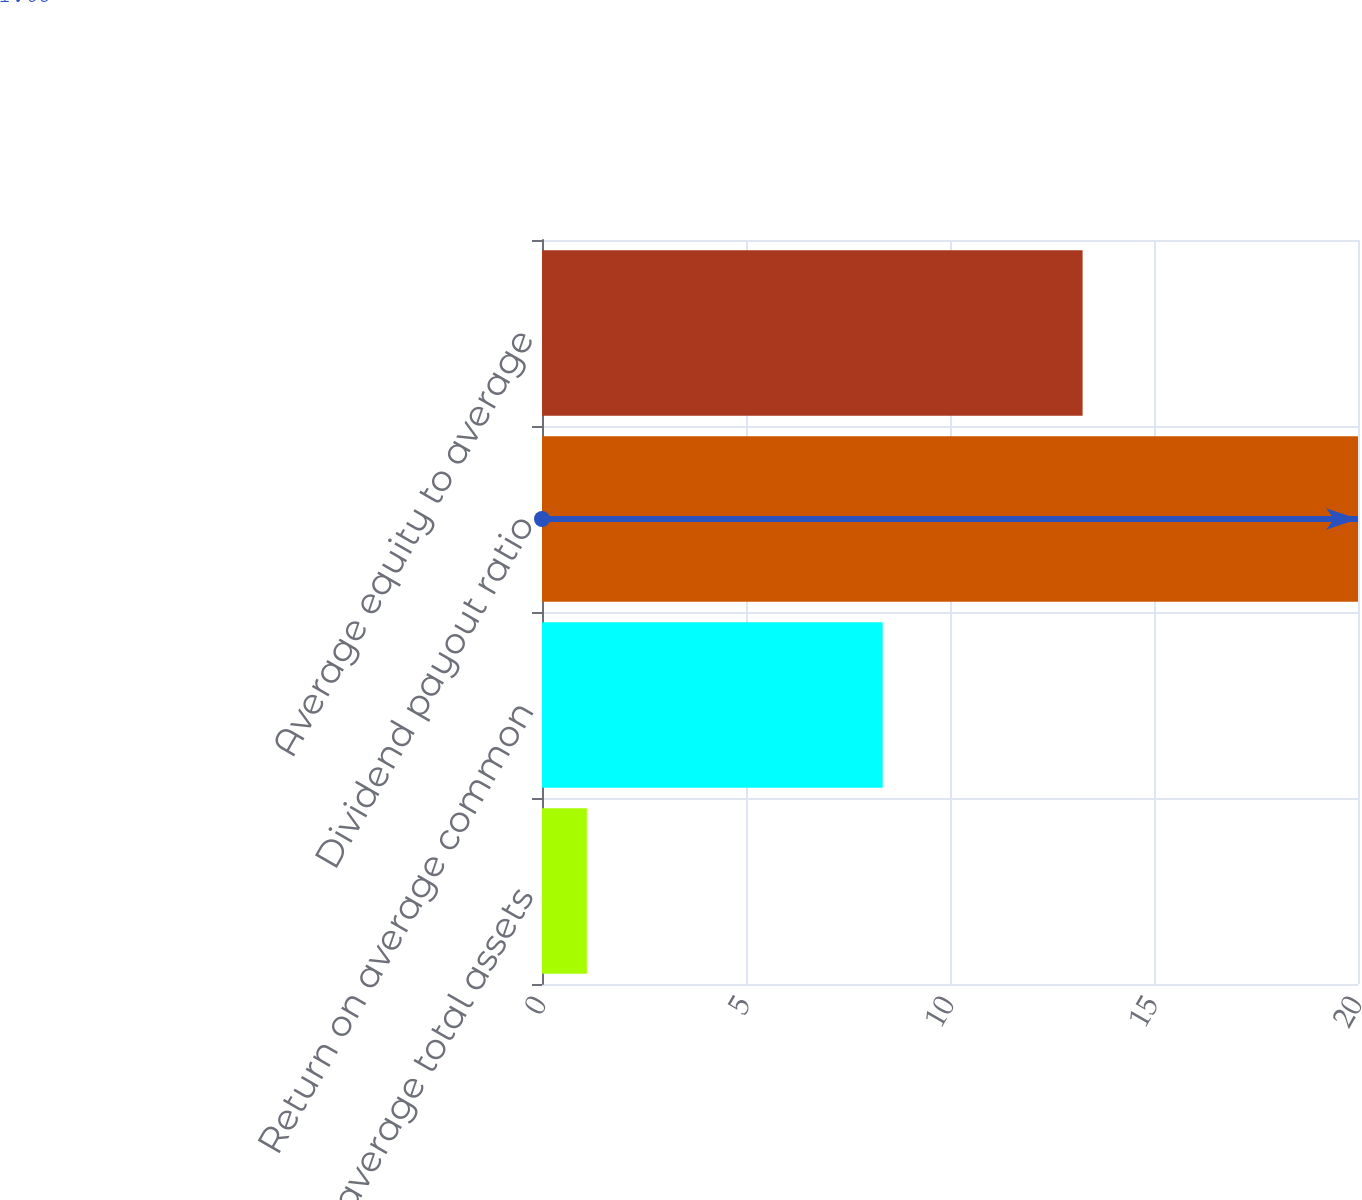<chart> <loc_0><loc_0><loc_500><loc_500><bar_chart><fcel>Return on average total assets<fcel>Return on average common<fcel>Dividend payout ratio<fcel>Average equity to average<nl><fcel>1.1<fcel>8.35<fcel>20<fcel>13.25<nl></chart> 